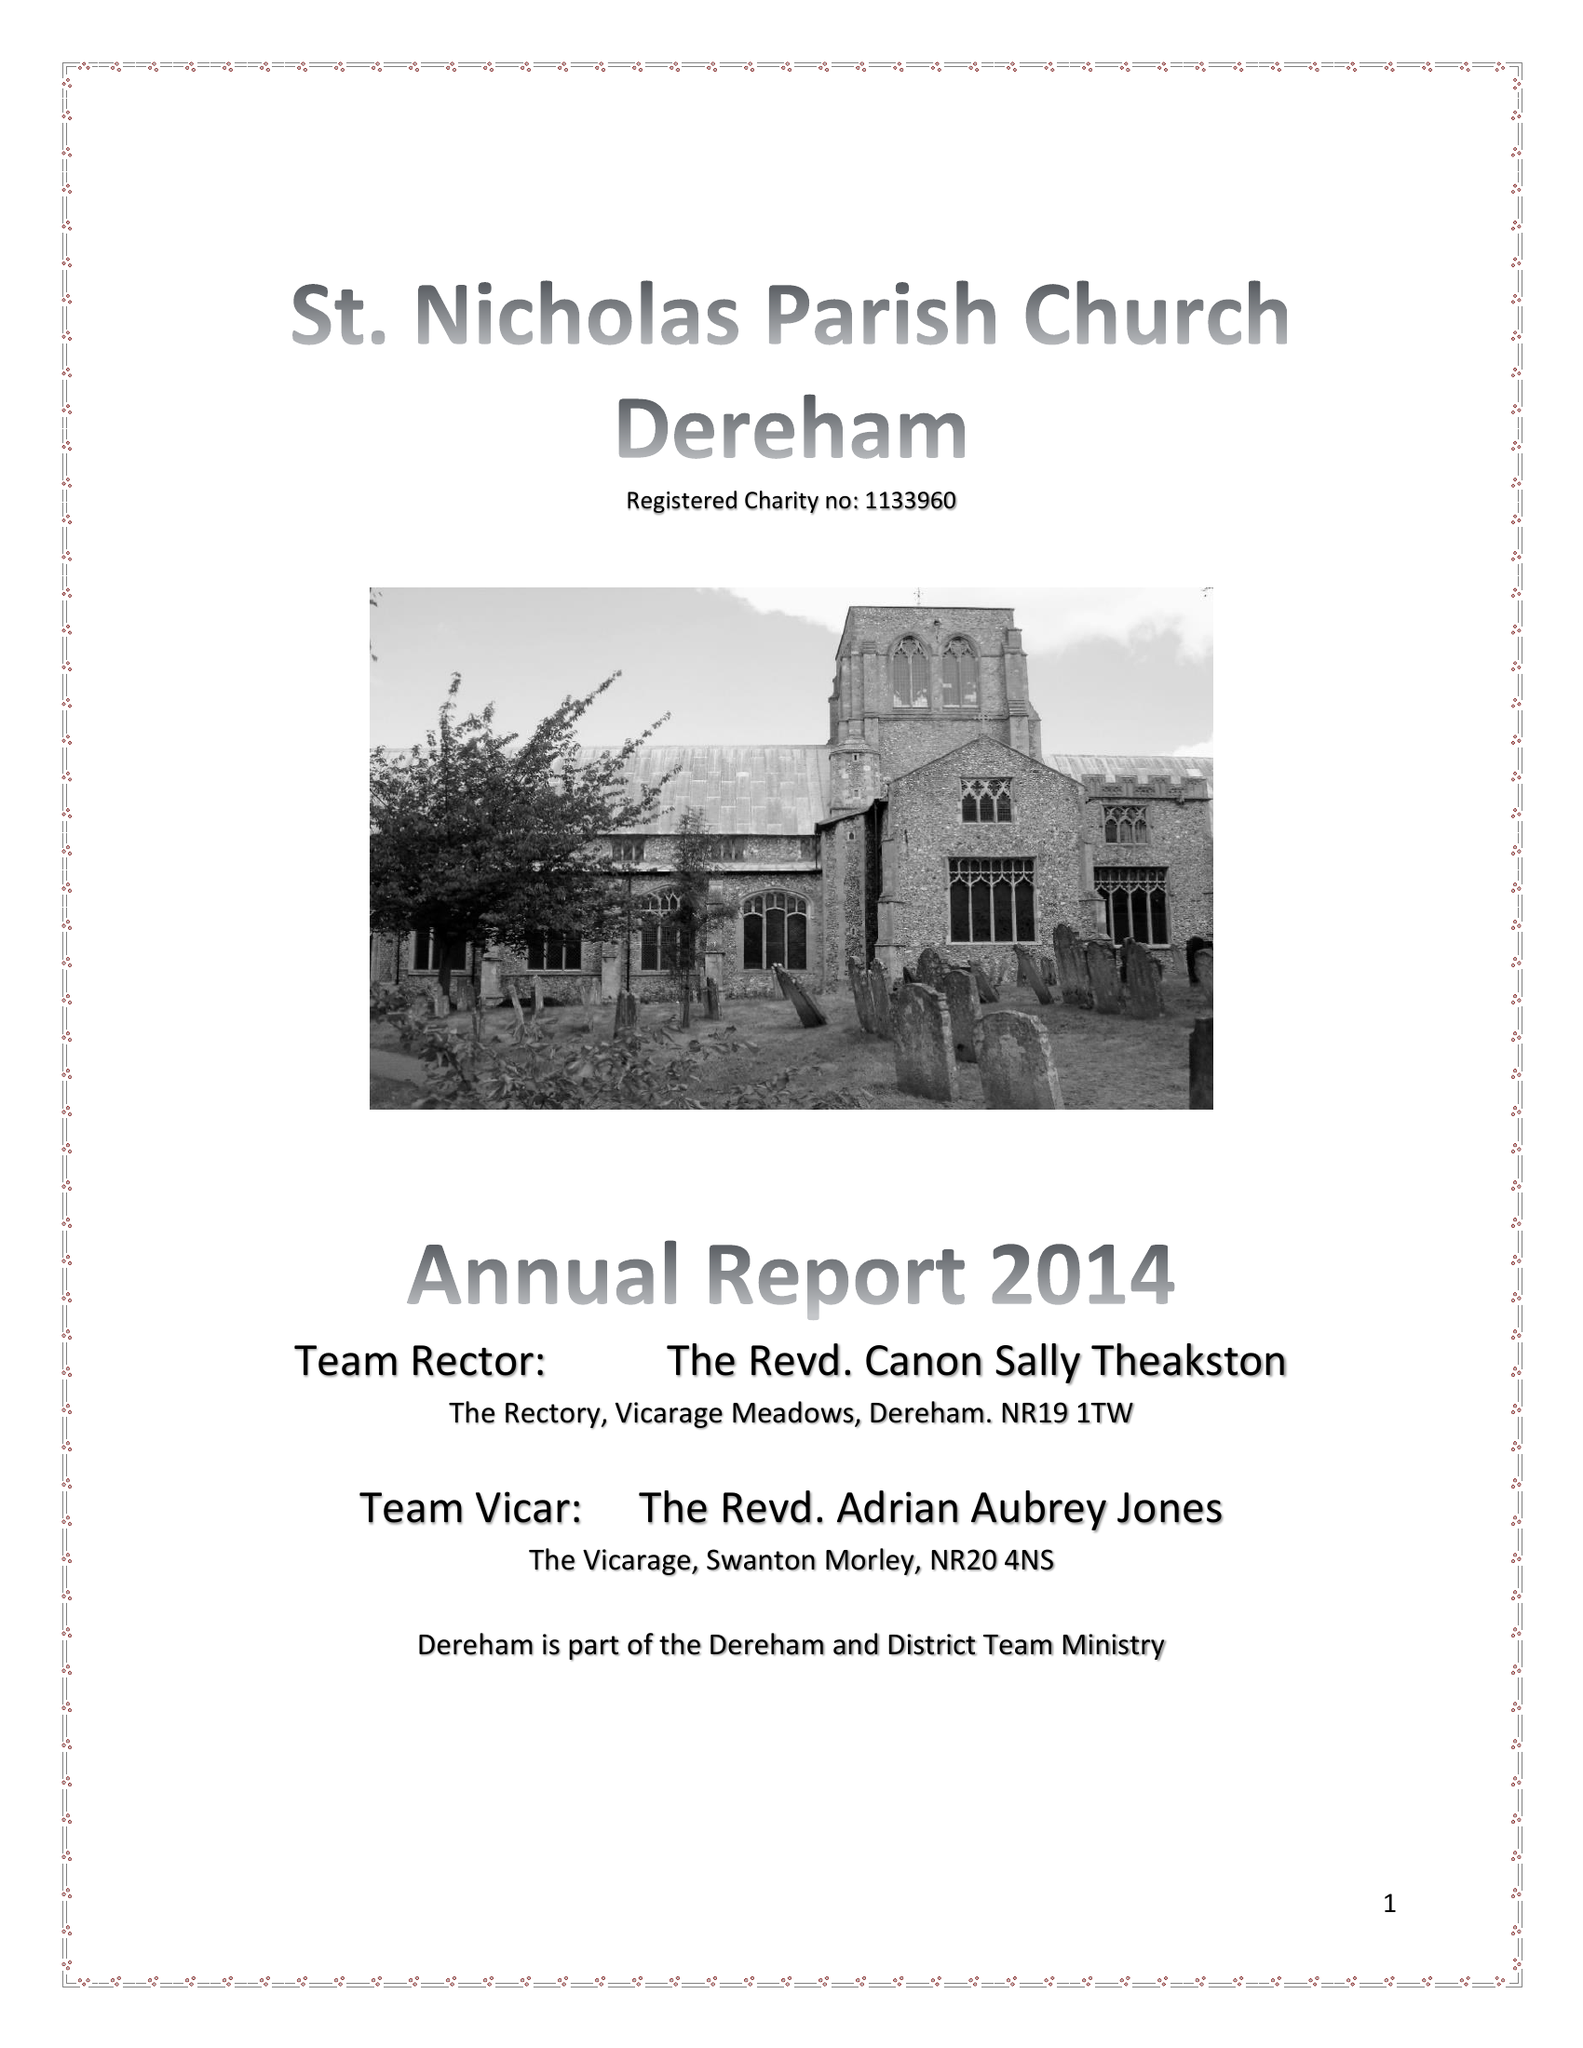What is the value for the spending_annually_in_british_pounds?
Answer the question using a single word or phrase. 101152.00 